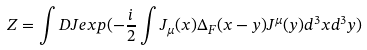Convert formula to latex. <formula><loc_0><loc_0><loc_500><loc_500>Z = \int D J e x p ( - \frac { i } { 2 } \int J _ { \mu } ( x ) \Delta _ { F } ( x - y ) J ^ { \mu } ( y ) d ^ { 3 } x d ^ { 3 } y )</formula> 